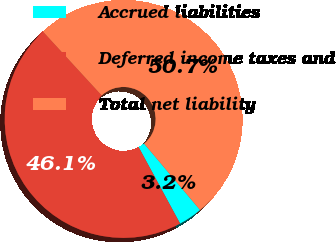Convert chart. <chart><loc_0><loc_0><loc_500><loc_500><pie_chart><fcel>Accrued liabilities<fcel>Deferred income taxes and<fcel>Total net liability<nl><fcel>3.24%<fcel>46.07%<fcel>50.68%<nl></chart> 